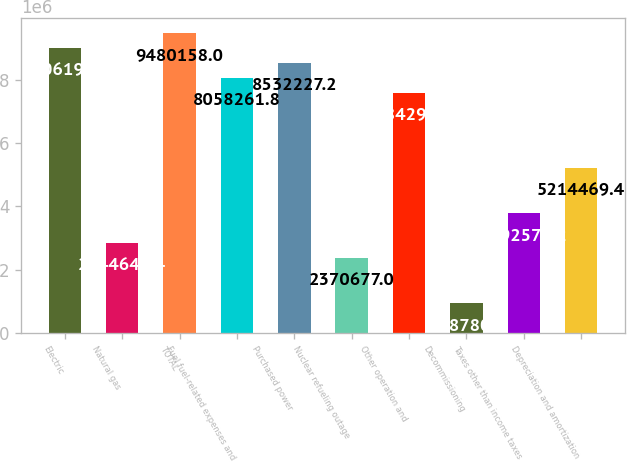<chart> <loc_0><loc_0><loc_500><loc_500><bar_chart><fcel>Electric<fcel>Natural gas<fcel>TOTAL<fcel>Fuel fuel-related expenses and<fcel>Purchased power<fcel>Nuclear refueling outage<fcel>Other operation and<fcel>Decommissioning<fcel>Taxes other than income taxes<fcel>Depreciation and amortization<nl><fcel>9.00619e+06<fcel>2.84464e+06<fcel>9.48016e+06<fcel>8.05826e+06<fcel>8.53223e+06<fcel>2.37068e+06<fcel>7.5843e+06<fcel>948781<fcel>3.79257e+06<fcel>5.21447e+06<nl></chart> 